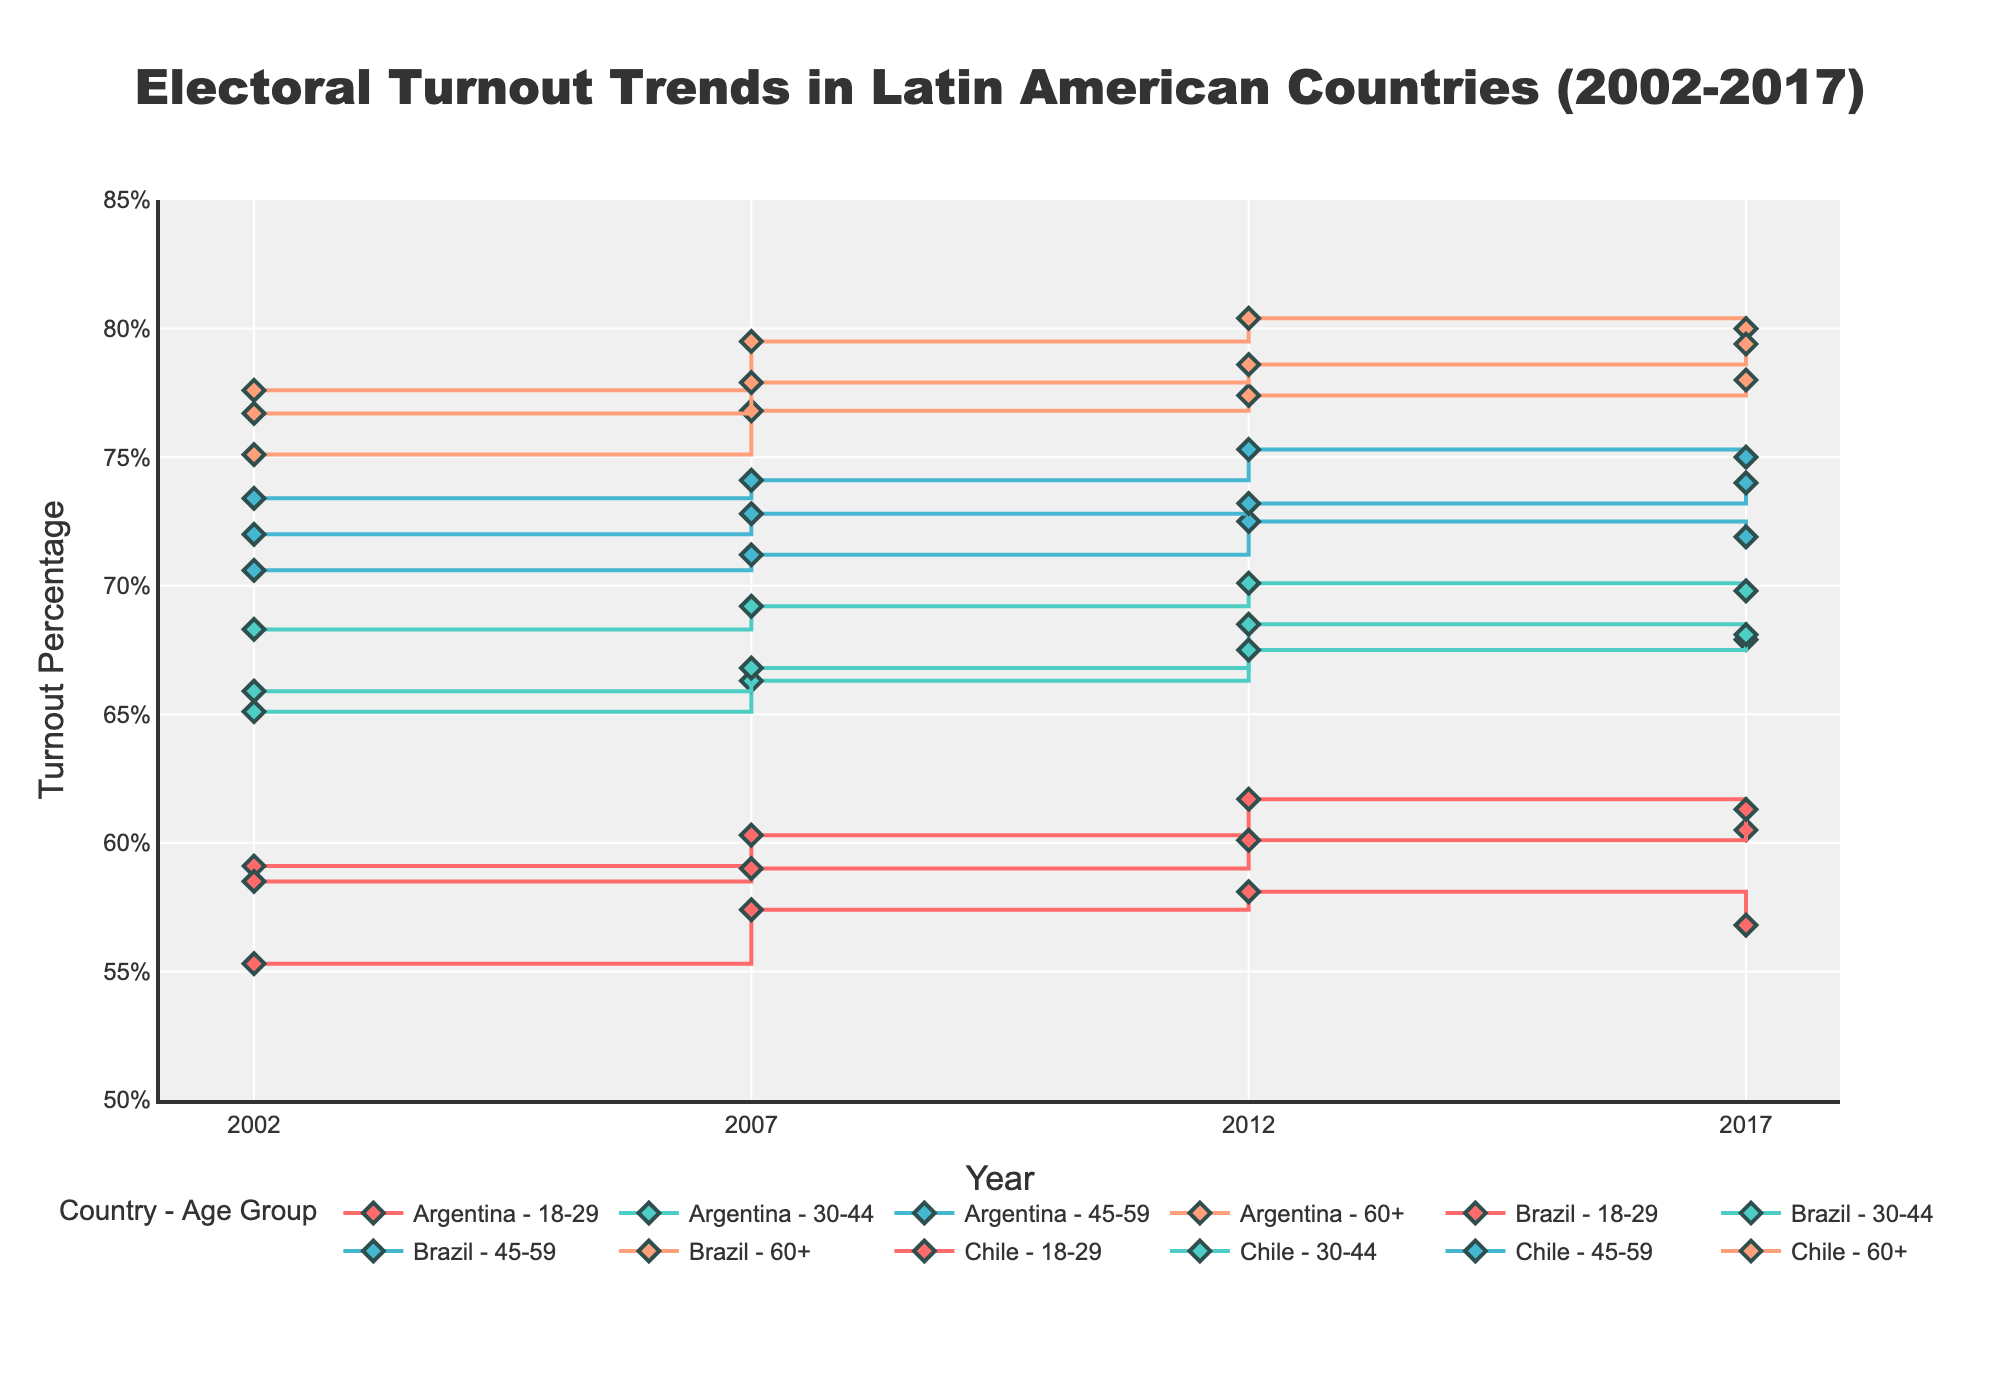What's the title of the figure? The title is prominently displayed at the top of the figure. It reads "Electoral Turnout Trends in Latin American Countries (2002-2017)".
Answer: Electoral Turnout Trends in Latin American Countries (2002-2017) How many countries are represented in the figure? To determine the number of countries, look at the labels for each line in the legend. There are entries for Argentina, Brazil, and Chile, indicating that three countries are represented.
Answer: 3 How does the electoral turnout of the 18-29 age group in Argentina in 2002 compare to 2017? To find this, locate the line representing Argentina's 18-29 age group and compare the turnout percentage at the years 2002 and 2017. In 2002 the turnout was 55.3%, and in 2017 it was 56.8%.
Answer: Increased from 55.3% to 56.8% Which age group in Brazil had the highest turnout percentage in 2017? Examine the lines for Brazil and look for the highest point in 2017. The age group 60+ shows the highest turnout at 80.0%.
Answer: 60+ What is the difference in turnout between the 18-29 and 60+ age groups in Chile in 2012? Locate the lines for Chile's 18-29 and 60+ age groups in 2012. Subtract the turnout for the 18-29 group (60.1%) from the 60+ group (78.6%). The difference is 18.5%.
Answer: 18.5% Which country showed the highest increase in turnout for the 30-44 age group from 2002 to 2017? Calculate the increase in turnout for each country in the 30-44 age group from 2002 to 2017. Argentina increased from 65.1% to 67.9% (+2.8%), Brazil from 68.3% to 69.8% (+1.5%), and Chile from 65.9% to 68.1% (+2.2%). Argentina shows the highest increase.
Answer: Argentina In which year was the turnout highest for the 45-59 age group in Argentina? Review the line representing Argentina's 45-59 age group and identify the year with the highest value. In 2012, the turnout was at its highest at 72.5%.
Answer: 2012 What is the average turnout percentage for the 60+ age group in Brazil over the 20-year period? To compute this, average the values for 60+ in Brazil across all years: (77.6 + 79.5 + 80.4 + 80.0) / 4 = 79.375%.
Answer: 79.375% Which country's 18-29 age group experienced the smallest fluctuation in turnout percentages over the years? Compare the turnout ranges for the 18-29 age group across all countries by finding the difference between the highest and lowest turnouts. Argentina’s range is 2.8%, Brazil’s is 2.6%, and Chile’s is 2.8%. Brazil experienced the smallest fluctuation.
Answer: Brazil Do any of the age groups in any country show a continuous increase in turnout from 2002 to 2017? Review the lines for each age group in each country to check for a continuously increasing trend. Chile's 18-29 age group shows a continuous increase from 58.5% in 2002 to 61.3% in 2017.
Answer: Yes, Chile 18-29 